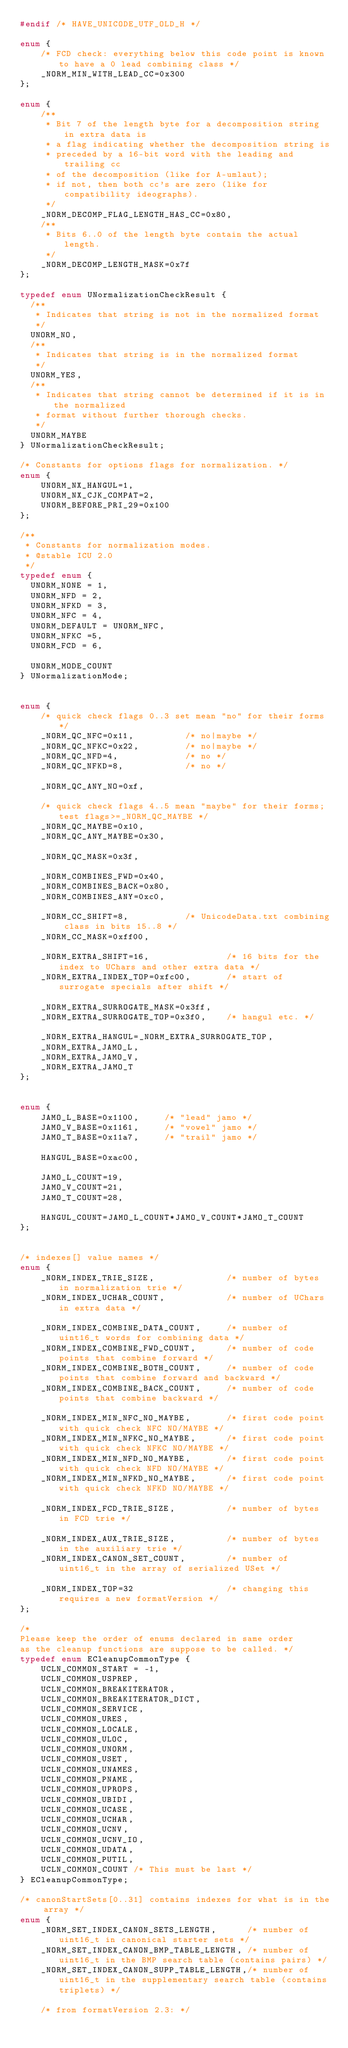<code> <loc_0><loc_0><loc_500><loc_500><_C_>#endif /* HAVE_UNICODE_UTF_OLD_H */

enum {
    /* FCD check: everything below this code point is known to have a 0 lead combining class */
    _NORM_MIN_WITH_LEAD_CC=0x300
};

enum {
    /**
     * Bit 7 of the length byte for a decomposition string in extra data is
     * a flag indicating whether the decomposition string is
     * preceded by a 16-bit word with the leading and trailing cc
     * of the decomposition (like for A-umlaut);
     * if not, then both cc's are zero (like for compatibility ideographs).
     */
    _NORM_DECOMP_FLAG_LENGTH_HAS_CC=0x80,
    /**
     * Bits 6..0 of the length byte contain the actual length.
     */
    _NORM_DECOMP_LENGTH_MASK=0x7f
};

typedef enum UNormalizationCheckResult {
  /** 
   * Indicates that string is not in the normalized format
   */
  UNORM_NO,
  /** 
   * Indicates that string is in the normalized format
   */
  UNORM_YES,
  /** 
   * Indicates that string cannot be determined if it is in the normalized 
   * format without further thorough checks.
   */
  UNORM_MAYBE
} UNormalizationCheckResult;

/* Constants for options flags for normalization. */
enum {
    UNORM_NX_HANGUL=1,
    UNORM_NX_CJK_COMPAT=2,
    UNORM_BEFORE_PRI_29=0x100
};

/**
 * Constants for normalization modes.
 * @stable ICU 2.0
 */
typedef enum {
  UNORM_NONE = 1, 
  UNORM_NFD = 2,
  UNORM_NFKD = 3,
  UNORM_NFC = 4,
  UNORM_DEFAULT = UNORM_NFC, 
  UNORM_NFKC =5,
  UNORM_FCD = 6,

  UNORM_MODE_COUNT
} UNormalizationMode;


enum {
    /* quick check flags 0..3 set mean "no" for their forms */
    _NORM_QC_NFC=0x11,          /* no|maybe */
    _NORM_QC_NFKC=0x22,         /* no|maybe */
    _NORM_QC_NFD=4,             /* no */
    _NORM_QC_NFKD=8,            /* no */

    _NORM_QC_ANY_NO=0xf,

    /* quick check flags 4..5 mean "maybe" for their forms; test flags>=_NORM_QC_MAYBE */
    _NORM_QC_MAYBE=0x10,
    _NORM_QC_ANY_MAYBE=0x30,

    _NORM_QC_MASK=0x3f,

    _NORM_COMBINES_FWD=0x40,
    _NORM_COMBINES_BACK=0x80,
    _NORM_COMBINES_ANY=0xc0,

    _NORM_CC_SHIFT=8,           /* UnicodeData.txt combining class in bits 15..8 */
    _NORM_CC_MASK=0xff00,

    _NORM_EXTRA_SHIFT=16,               /* 16 bits for the index to UChars and other extra data */
    _NORM_EXTRA_INDEX_TOP=0xfc00,       /* start of surrogate specials after shift */

    _NORM_EXTRA_SURROGATE_MASK=0x3ff,
    _NORM_EXTRA_SURROGATE_TOP=0x3f0,    /* hangul etc. */

    _NORM_EXTRA_HANGUL=_NORM_EXTRA_SURROGATE_TOP,
    _NORM_EXTRA_JAMO_L,
    _NORM_EXTRA_JAMO_V,
    _NORM_EXTRA_JAMO_T
};


enum {
    JAMO_L_BASE=0x1100,     /* "lead" jamo */
    JAMO_V_BASE=0x1161,     /* "vowel" jamo */
    JAMO_T_BASE=0x11a7,     /* "trail" jamo */

    HANGUL_BASE=0xac00,

    JAMO_L_COUNT=19,
    JAMO_V_COUNT=21,
    JAMO_T_COUNT=28,

    HANGUL_COUNT=JAMO_L_COUNT*JAMO_V_COUNT*JAMO_T_COUNT
};


/* indexes[] value names */
enum {
    _NORM_INDEX_TRIE_SIZE,              /* number of bytes in normalization trie */
    _NORM_INDEX_UCHAR_COUNT,            /* number of UChars in extra data */

    _NORM_INDEX_COMBINE_DATA_COUNT,     /* number of uint16_t words for combining data */
    _NORM_INDEX_COMBINE_FWD_COUNT,      /* number of code points that combine forward */
    _NORM_INDEX_COMBINE_BOTH_COUNT,     /* number of code points that combine forward and backward */
    _NORM_INDEX_COMBINE_BACK_COUNT,     /* number of code points that combine backward */

    _NORM_INDEX_MIN_NFC_NO_MAYBE,       /* first code point with quick check NFC NO/MAYBE */
    _NORM_INDEX_MIN_NFKC_NO_MAYBE,      /* first code point with quick check NFKC NO/MAYBE */
    _NORM_INDEX_MIN_NFD_NO_MAYBE,       /* first code point with quick check NFD NO/MAYBE */
    _NORM_INDEX_MIN_NFKD_NO_MAYBE,      /* first code point with quick check NFKD NO/MAYBE */

    _NORM_INDEX_FCD_TRIE_SIZE,          /* number of bytes in FCD trie */

    _NORM_INDEX_AUX_TRIE_SIZE,          /* number of bytes in the auxiliary trie */
    _NORM_INDEX_CANON_SET_COUNT,        /* number of uint16_t in the array of serialized USet */

    _NORM_INDEX_TOP=32                  /* changing this requires a new formatVersion */
};

/*
Please keep the order of enums declared in same order
as the cleanup functions are suppose to be called. */
typedef enum ECleanupCommonType {
    UCLN_COMMON_START = -1,
    UCLN_COMMON_USPREP,
    UCLN_COMMON_BREAKITERATOR,
    UCLN_COMMON_BREAKITERATOR_DICT,
    UCLN_COMMON_SERVICE,
    UCLN_COMMON_URES,
    UCLN_COMMON_LOCALE,
    UCLN_COMMON_ULOC,
    UCLN_COMMON_UNORM,
    UCLN_COMMON_USET,
    UCLN_COMMON_UNAMES,
    UCLN_COMMON_PNAME,
    UCLN_COMMON_UPROPS,
    UCLN_COMMON_UBIDI,
    UCLN_COMMON_UCASE,
    UCLN_COMMON_UCHAR,
    UCLN_COMMON_UCNV,
    UCLN_COMMON_UCNV_IO,
    UCLN_COMMON_UDATA,
    UCLN_COMMON_PUTIL,
    UCLN_COMMON_COUNT /* This must be last */
} ECleanupCommonType;

/* canonStartSets[0..31] contains indexes for what is in the array */
enum {
    _NORM_SET_INDEX_CANON_SETS_LENGTH,      /* number of uint16_t in canonical starter sets */
    _NORM_SET_INDEX_CANON_BMP_TABLE_LENGTH, /* number of uint16_t in the BMP search table (contains pairs) */
    _NORM_SET_INDEX_CANON_SUPP_TABLE_LENGTH,/* number of uint16_t in the supplementary search table (contains triplets) */

    /* from formatVersion 2.3: */</code> 